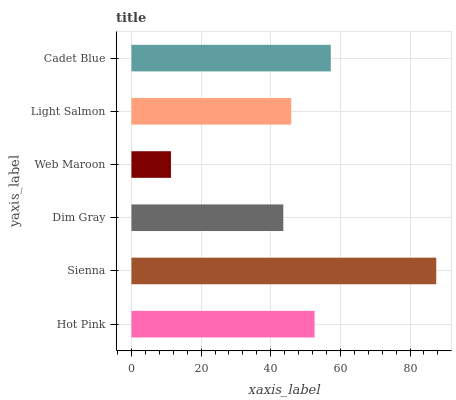Is Web Maroon the minimum?
Answer yes or no. Yes. Is Sienna the maximum?
Answer yes or no. Yes. Is Dim Gray the minimum?
Answer yes or no. No. Is Dim Gray the maximum?
Answer yes or no. No. Is Sienna greater than Dim Gray?
Answer yes or no. Yes. Is Dim Gray less than Sienna?
Answer yes or no. Yes. Is Dim Gray greater than Sienna?
Answer yes or no. No. Is Sienna less than Dim Gray?
Answer yes or no. No. Is Hot Pink the high median?
Answer yes or no. Yes. Is Light Salmon the low median?
Answer yes or no. Yes. Is Light Salmon the high median?
Answer yes or no. No. Is Web Maroon the low median?
Answer yes or no. No. 